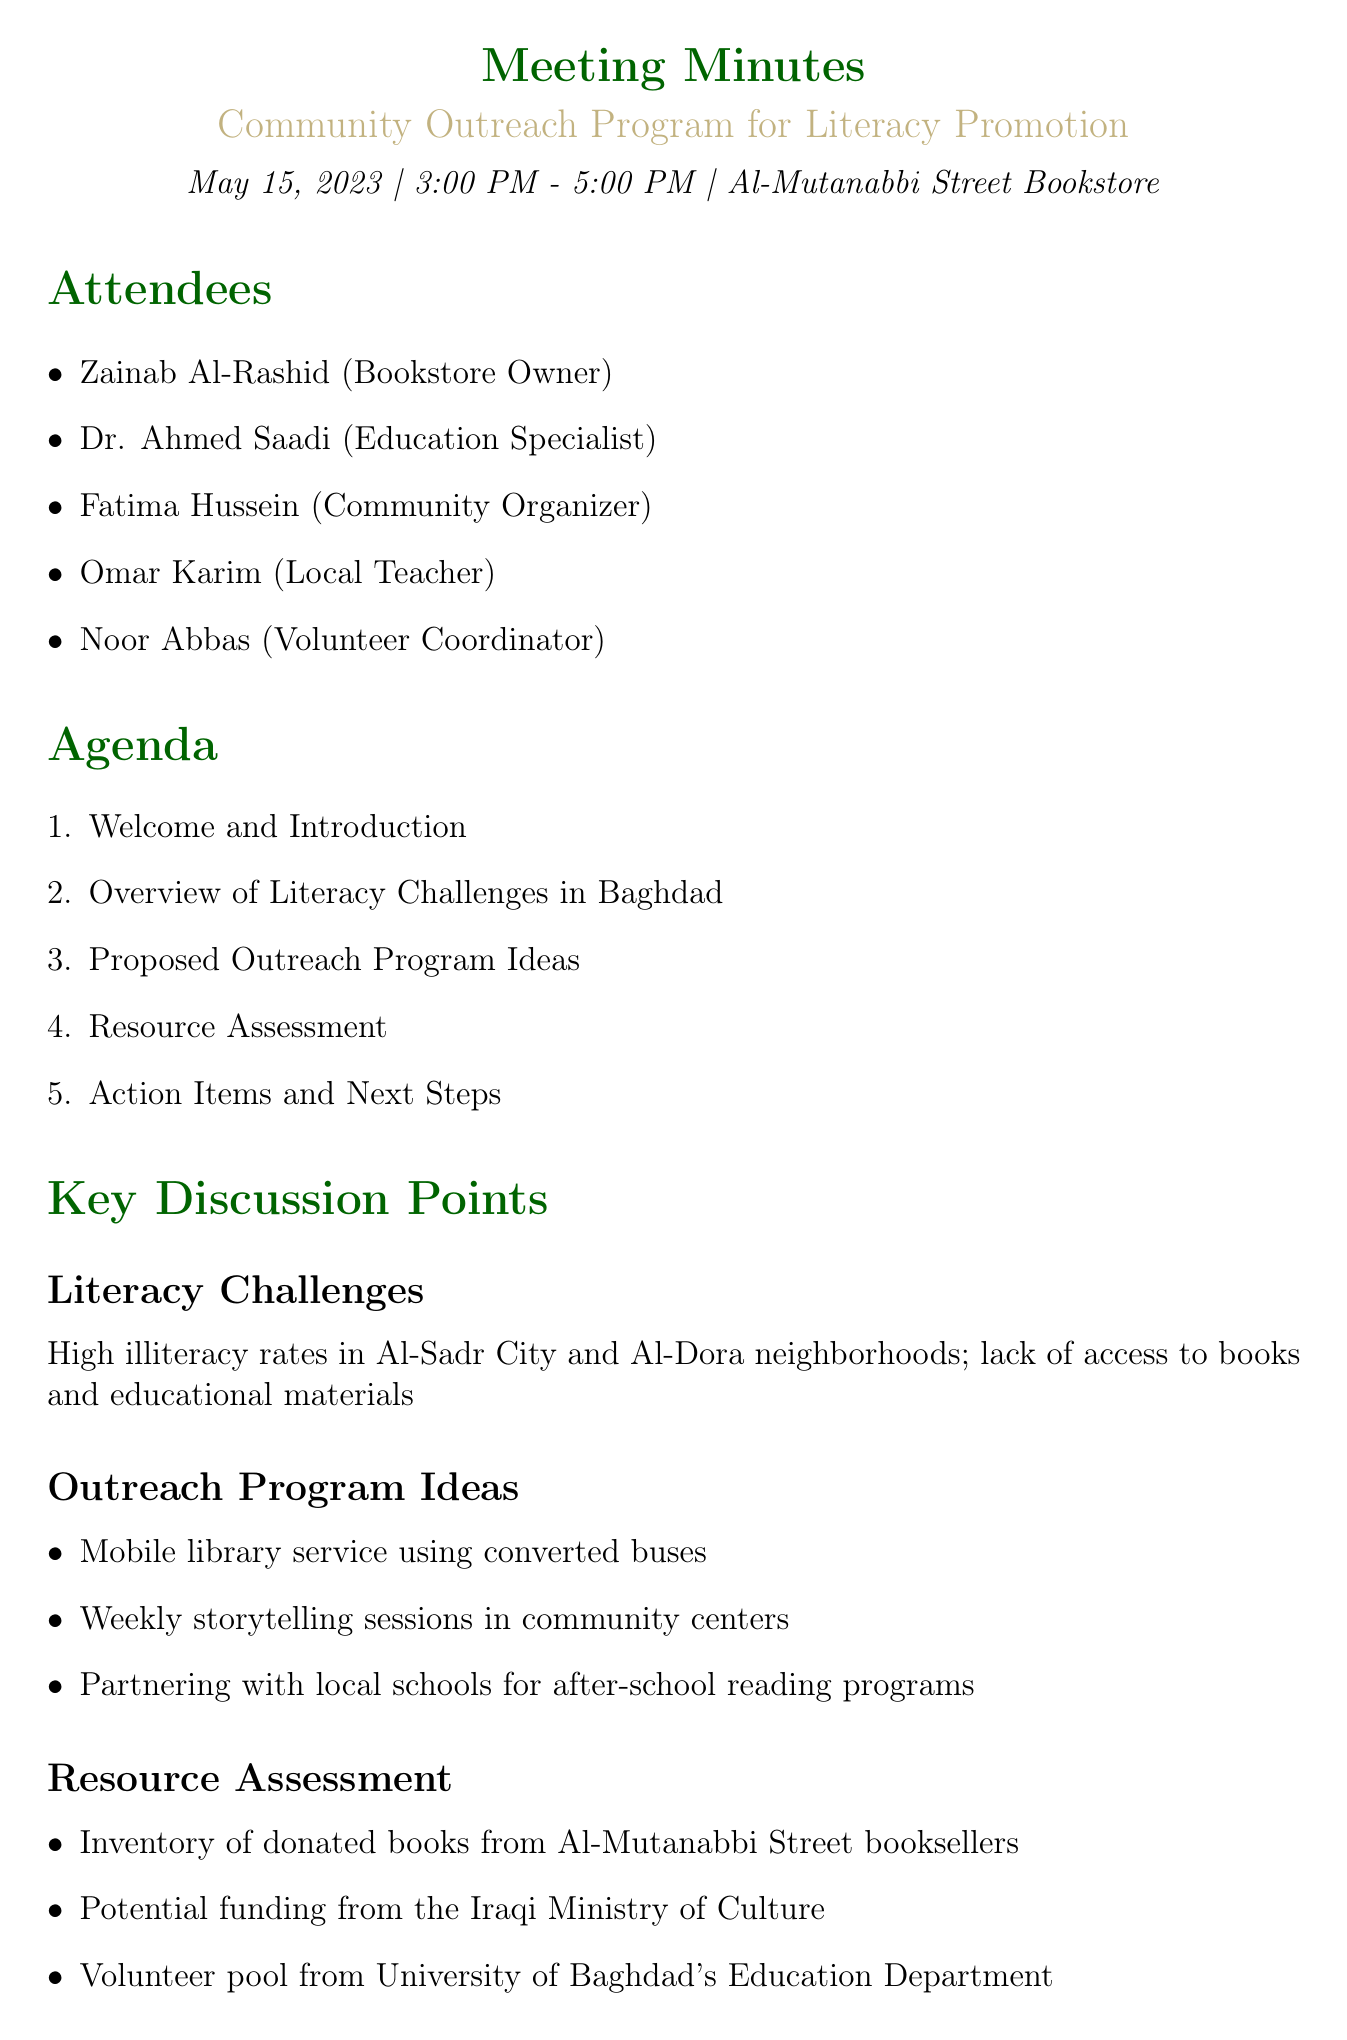What is the date of the meeting? The date of the meeting is explicitly stated at the beginning of the document as May 15, 2023.
Answer: May 15, 2023 Who is the community organizer attending the meeting? The document lists the attendees, including the role of each person. Fatima Hussein is noted as the Community Organizer.
Answer: Fatima Hussein What are the proposed outreach program ideas? The document outlines the proposed ideas under the key discussion points section, specifically mentioning mobile library service, storytelling sessions, and partnering with schools.
Answer: Mobile library service, Weekly storytelling sessions, Partnering with local schools How long did the meeting last? The meeting is scheduled from 3:00 PM to 5:00 PM, which can be used to calculate the duration.
Answer: 2 hours What action item is assigned to Dr. Saadi? The action items section indicates that Dr. Saadi is tasked with drafting a proposal for funding.
Answer: Draft proposal for Ministry of Culture funding When is the next meeting scheduled? The next meeting's date and time are listed explicitly in the document.
Answer: June 1, 2023 What is a primary literacy challenge mentioned? The document highlights high illiteracy rates in specific neighborhoods as a core challenge.
Answer: High illiteracy rates Which coordinator is responsible for creating a volunteer recruitment plan? The action items specify that Noor is tasked with the recruitment plan for volunteers.
Answer: Noor Abbas 